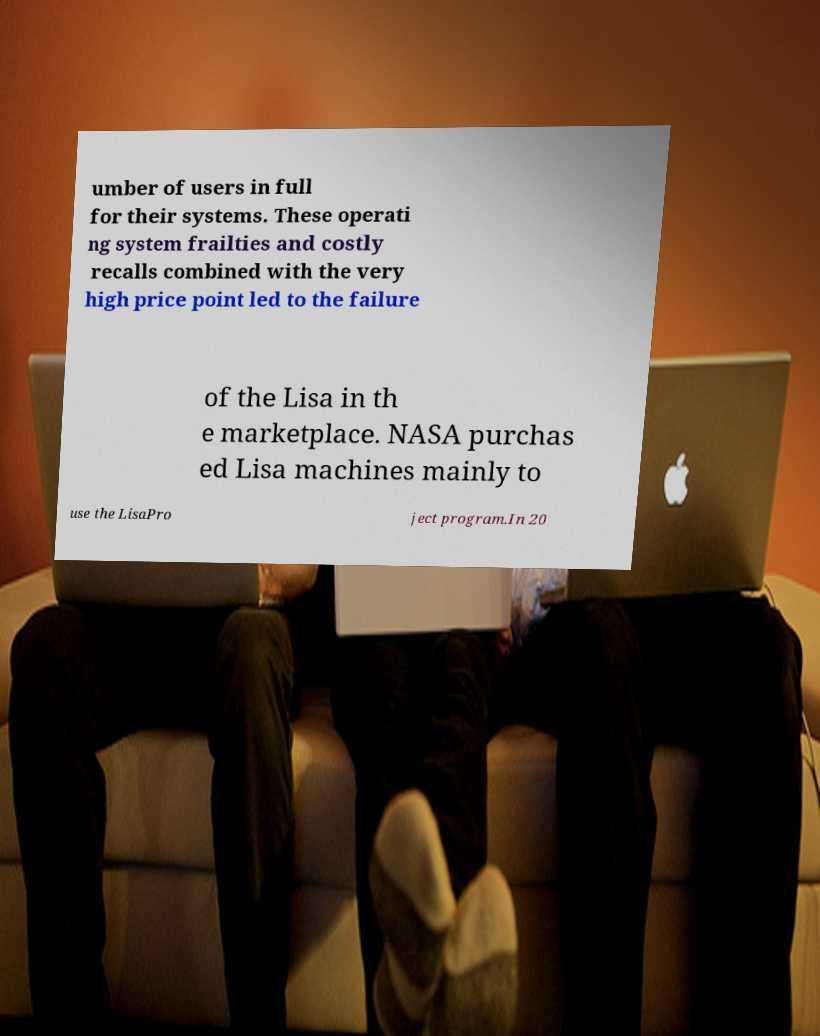Please identify and transcribe the text found in this image. umber of users in full for their systems. These operati ng system frailties and costly recalls combined with the very high price point led to the failure of the Lisa in th e marketplace. NASA purchas ed Lisa machines mainly to use the LisaPro ject program.In 20 